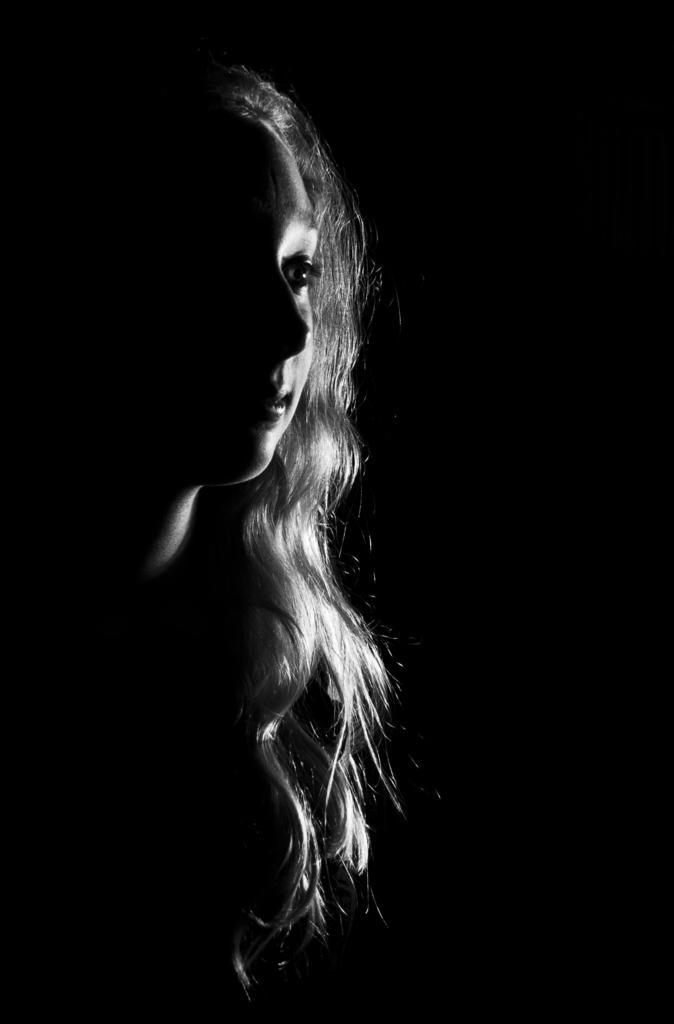What is the main subject of the image? There is a person in the image. What is the person doing in the image? The person is presenting. What type of beast can be seen wearing a cap in the image? There is no beast or cap present in the image; it features a person presenting. How long does the person present for in the image? The image does not provide information about the duration of the presentation, so it cannot be determined from the image. 